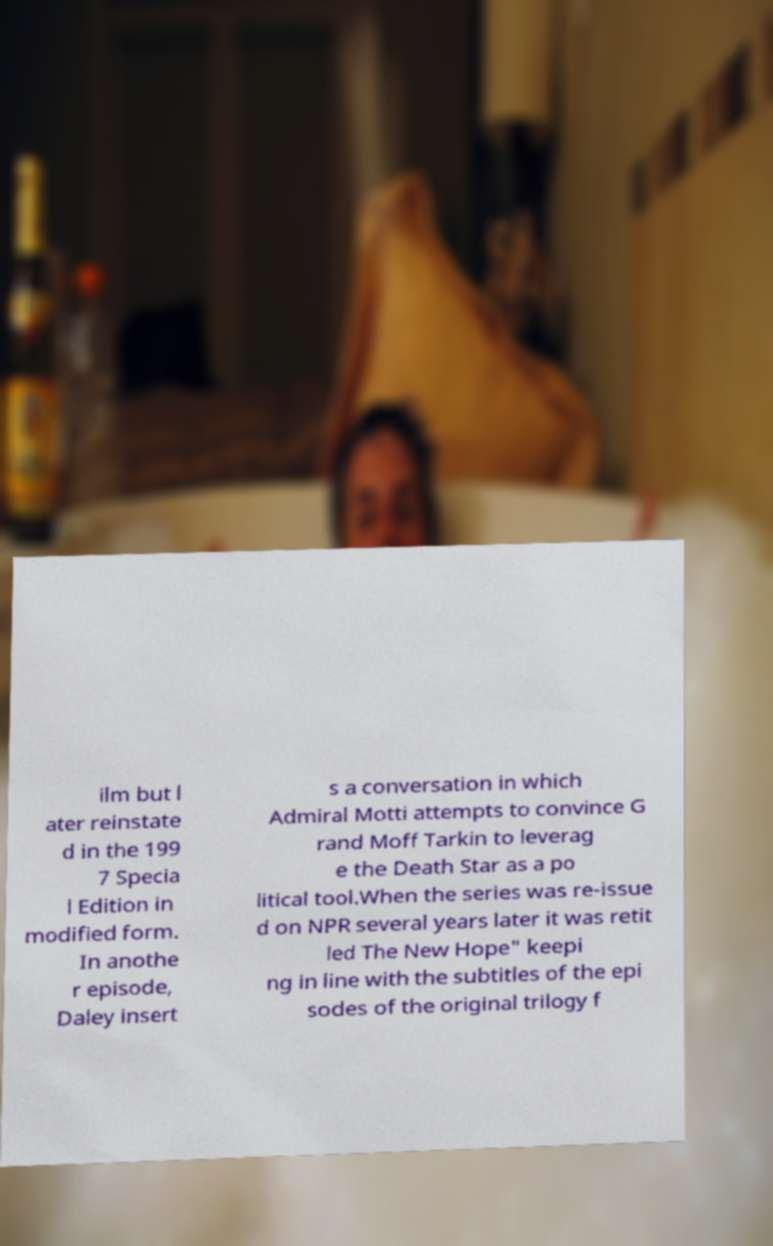There's text embedded in this image that I need extracted. Can you transcribe it verbatim? ilm but l ater reinstate d in the 199 7 Specia l Edition in modified form. In anothe r episode, Daley insert s a conversation in which Admiral Motti attempts to convince G rand Moff Tarkin to leverag e the Death Star as a po litical tool.When the series was re-issue d on NPR several years later it was retit led The New Hope" keepi ng in line with the subtitles of the epi sodes of the original trilogy f 